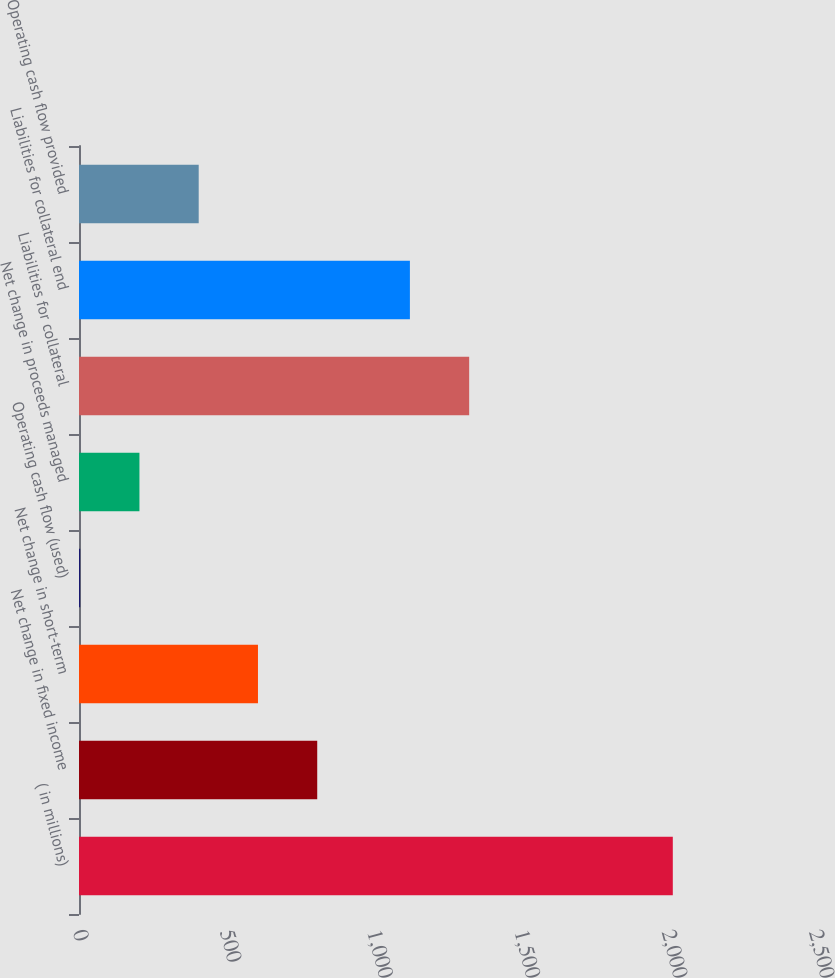Convert chart. <chart><loc_0><loc_0><loc_500><loc_500><bar_chart><fcel>( in millions)<fcel>Net change in fixed income<fcel>Net change in short-term<fcel>Operating cash flow (used)<fcel>Net change in proceeds managed<fcel>Liabilities for collateral<fcel>Liabilities for collateral end<fcel>Operating cash flow provided<nl><fcel>2017<fcel>809.2<fcel>607.9<fcel>4<fcel>205.3<fcel>1325.3<fcel>1124<fcel>406.6<nl></chart> 